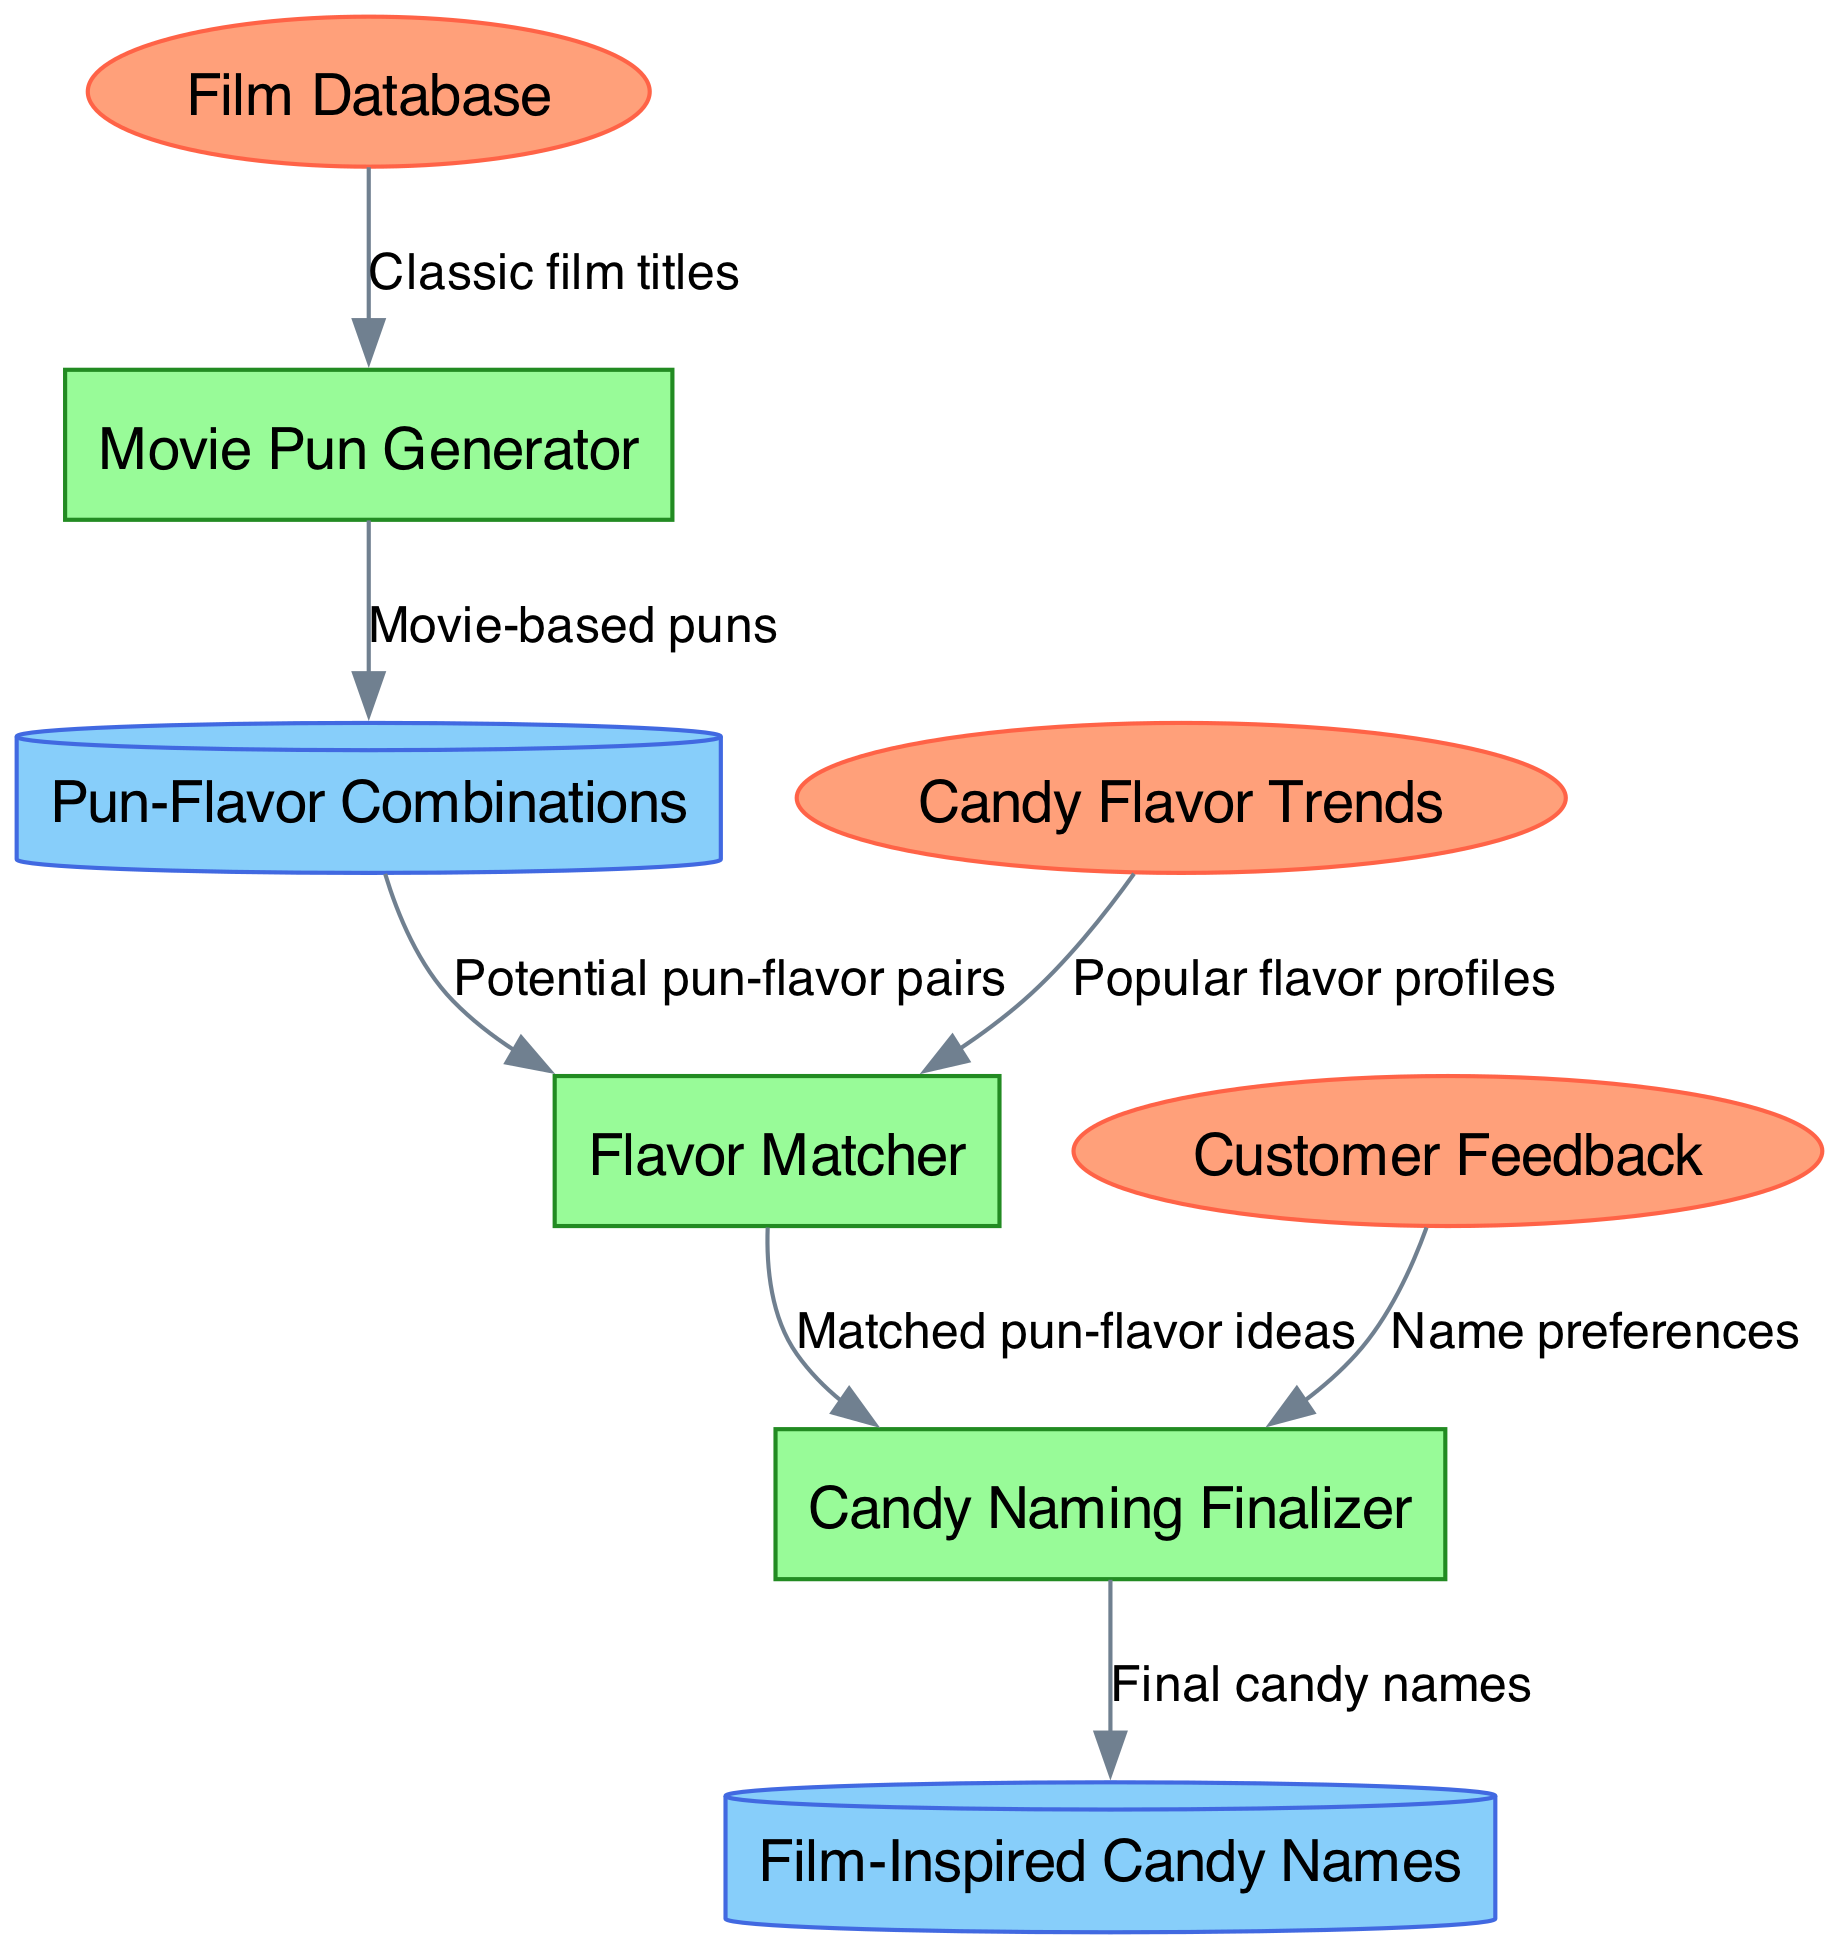What are the external entities in the diagram? The external entities are listed at the top, and they include Film Database, Customer Feedback, and Candy Flavor Trends. These entities represent the sources of data that interact with the processes in the diagram.
Answer: Film Database, Customer Feedback, Candy Flavor Trends How many processes are depicted in the diagram? There are three processes illustrated in the diagram: Movie Pun Generator, Flavor Matcher, and Candy Naming Finalizer. This count includes all processes involved in the candy flavor naming system.
Answer: 3 Which process receives data from Customer Feedback? The Candy Naming Finalizer receives data from Customer Feedback, as indicated by the directed arrow leading from Customer Feedback to that process. This signifies that customer preferences influence the final candy names.
Answer: Candy Naming Finalizer What data store holds the final candy names? The data store that holds the final candy names is Film-Inspired Candy Names, which is populated by the output of the Candy Naming Finalizer process. This signifies the culmination of the candy naming process.
Answer: Film-Inspired Candy Names What type of puns are generated from the Movie Pun Generator? The Movie Pun Generator produces movie-based puns, as indicated by the labeled flow from this process to the Pun-Flavor Combinations data store. This shows the nature of the puns being created.
Answer: Movie-based puns If popular flavor profiles are received, which process uses them next? The Flavor Matcher process uses the popular flavor profiles that are received from the Candy Flavor Trends external entity, as shown by the directed flow in the diagram. This flow indicates the integration of trending flavors for matching with potential puns.
Answer: Flavor Matcher How many data flows are represented in the diagram? The diagram represents six data flows that connect various external entities, processes, and data stores. Each flow illustrates the movement of information throughout the system.
Answer: 6 Which external entity provides classic film titles? The Film Database provides classic film titles, as indicated by the flow from this entity to the Movie Pun Generator process. This illustrates that the generator relies on these titles to create puns.
Answer: Film Database What is the output of the Candy Naming Finalizer? The output of the Candy Naming Finalizer is the final candy names, which are stored in the Film-Inspired Candy Names data store, as shown by the directed flow from the finalizer to this data store.
Answer: Final candy names 